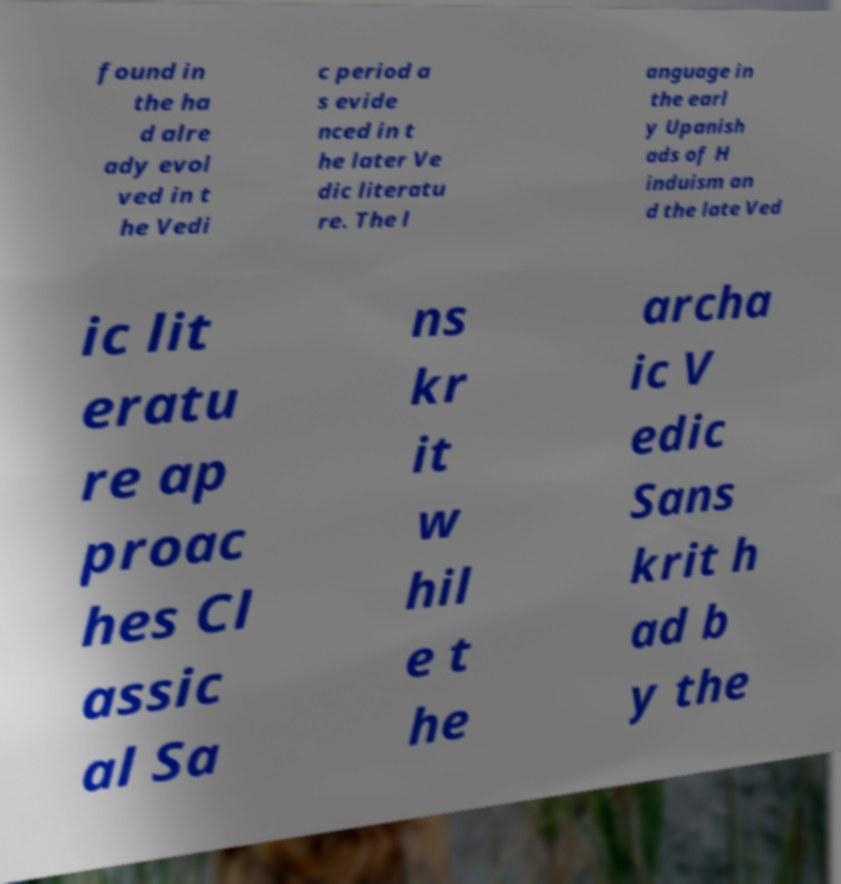For documentation purposes, I need the text within this image transcribed. Could you provide that? found in the ha d alre ady evol ved in t he Vedi c period a s evide nced in t he later Ve dic literatu re. The l anguage in the earl y Upanish ads of H induism an d the late Ved ic lit eratu re ap proac hes Cl assic al Sa ns kr it w hil e t he archa ic V edic Sans krit h ad b y the 